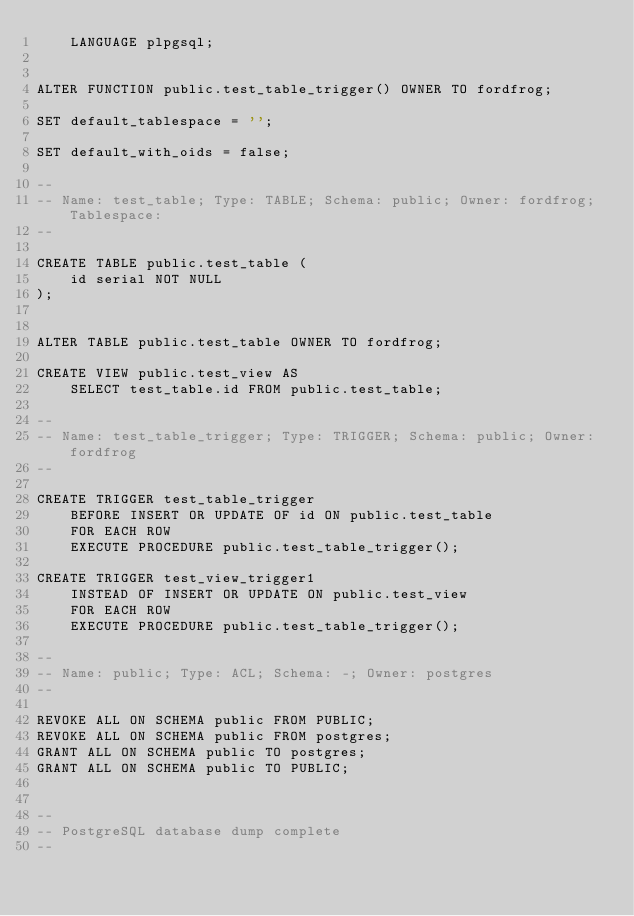Convert code to text. <code><loc_0><loc_0><loc_500><loc_500><_SQL_>    LANGUAGE plpgsql;


ALTER FUNCTION public.test_table_trigger() OWNER TO fordfrog;

SET default_tablespace = '';

SET default_with_oids = false;

--
-- Name: test_table; Type: TABLE; Schema: public; Owner: fordfrog; Tablespace: 
--

CREATE TABLE public.test_table (
    id serial NOT NULL
);


ALTER TABLE public.test_table OWNER TO fordfrog;

CREATE VIEW public.test_view AS 
    SELECT test_table.id FROM public.test_table;

--
-- Name: test_table_trigger; Type: TRIGGER; Schema: public; Owner: fordfrog
--

CREATE TRIGGER test_table_trigger
    BEFORE INSERT OR UPDATE OF id ON public.test_table
    FOR EACH ROW
    EXECUTE PROCEDURE public.test_table_trigger();

CREATE TRIGGER test_view_trigger1
    INSTEAD OF INSERT OR UPDATE ON public.test_view
    FOR EACH ROW
    EXECUTE PROCEDURE public.test_table_trigger();

--
-- Name: public; Type: ACL; Schema: -; Owner: postgres
--

REVOKE ALL ON SCHEMA public FROM PUBLIC;
REVOKE ALL ON SCHEMA public FROM postgres;
GRANT ALL ON SCHEMA public TO postgres;
GRANT ALL ON SCHEMA public TO PUBLIC;


--
-- PostgreSQL database dump complete
--

</code> 